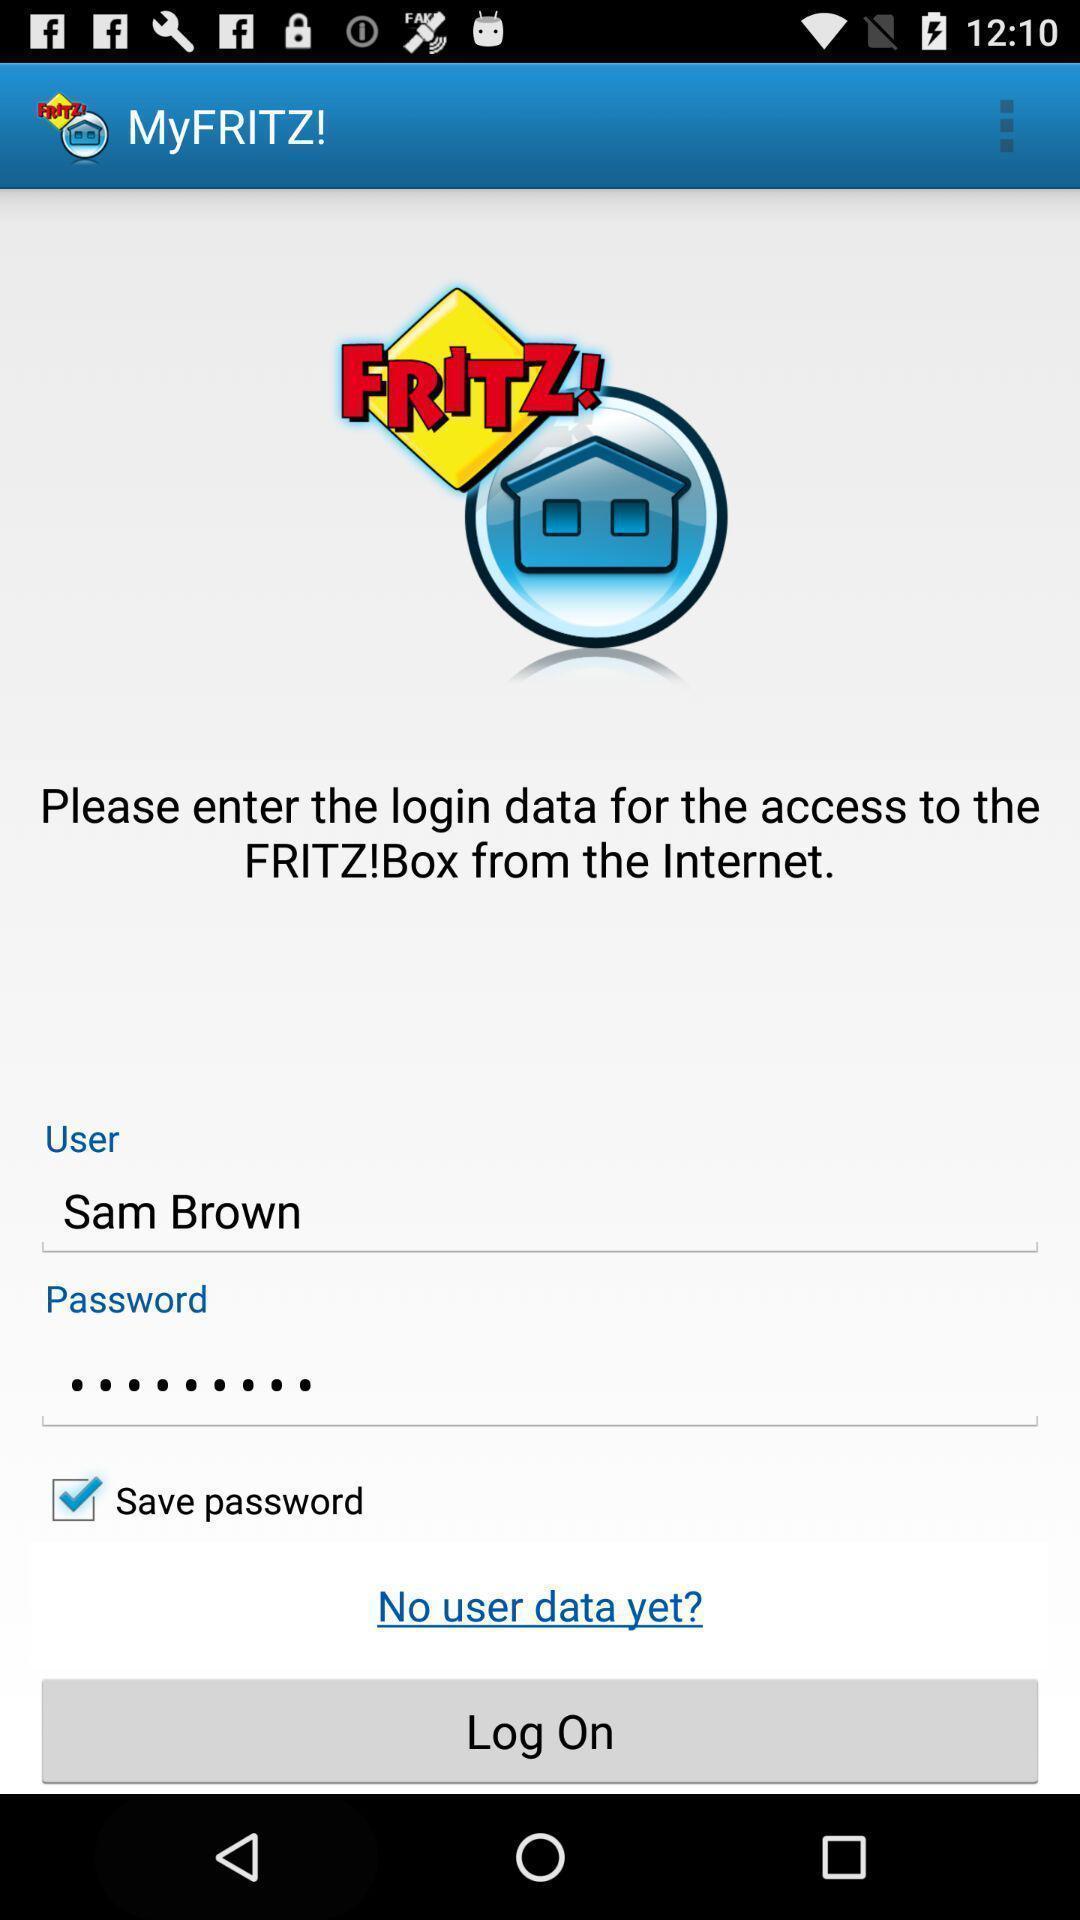Provide a detailed account of this screenshot. Page displaying to enter login details in app. 